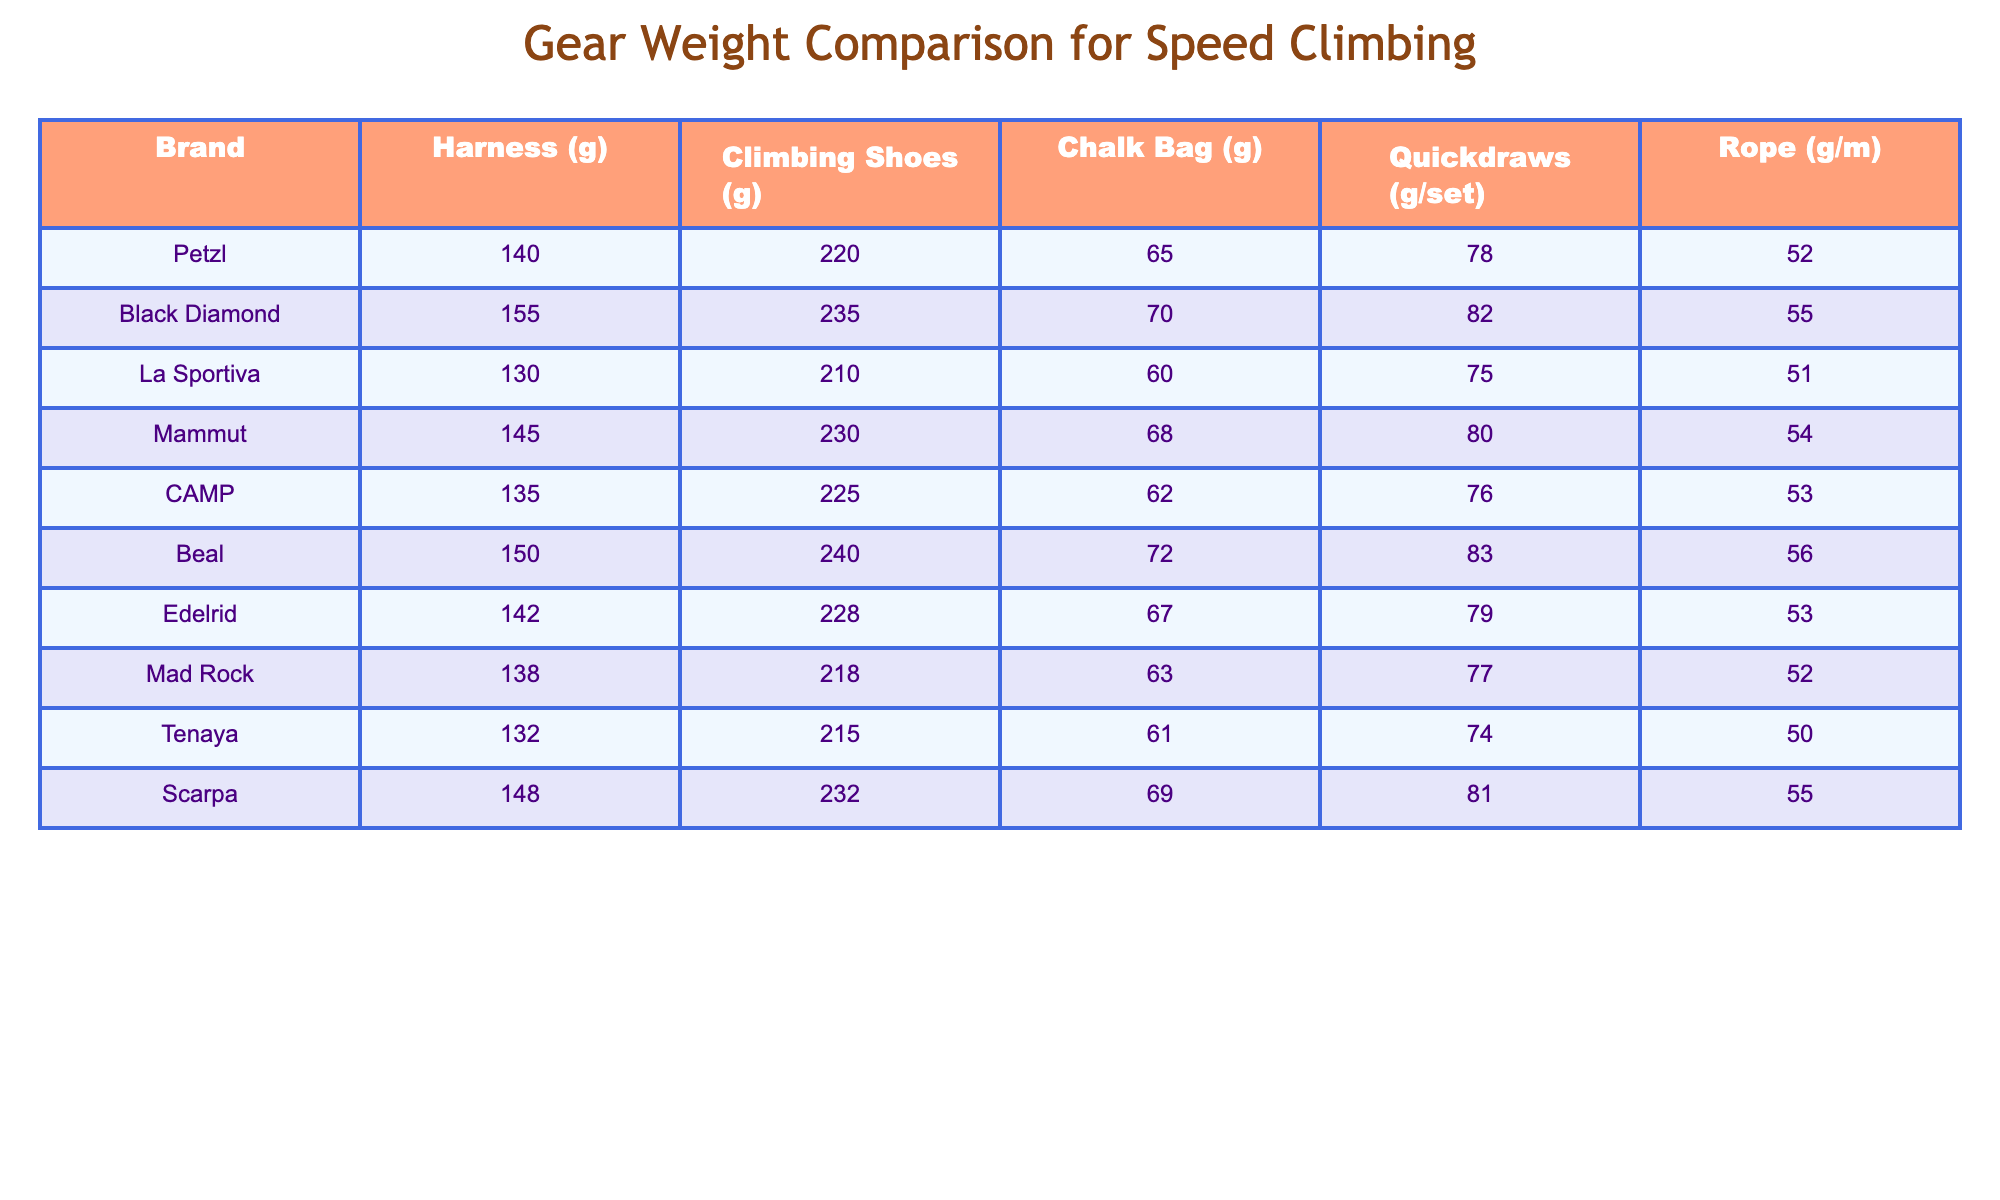What is the lightest harness among the brands? By comparing the weights of the harnesses listed in the table, Petzl has the lightest harness weight of 140 grams.
Answer: 140 grams Which brand has the heaviest climbing shoes? The table shows Black Diamond with climbing shoes weighing 235 grams, which is the heaviest among all the listed brands.
Answer: 235 grams How many grams do the quickdraws weigh if you combine the lightest and heaviest? The lightest quickdraws come from La Sportiva at 75 grams and the heaviest from Beal at 83 grams. The total weight is 75 + 83 = 158 grams.
Answer: 158 grams Is the weight of the Chalk Bag from CAMP heavier than that from Mad Rock? The Chalk Bag from CAMP weighs 62 grams, while Mad Rock's is 63 grams, making CAMP's chalk bag lighter.
Answer: No What is the average weight of the ropes across all brands? Adding all the rope weights gives 52 + 55 + 51 + 54 + 53 + 56 + 53 + 50 + 55 + 54 = 530 grams. Dividing this by the number of brands (10) results in an average of 53 grams.
Answer: 53 grams Which brand has the lightest overall gear weight, considering harness, climbing shoes, chalk bag, quickdraws, and rope? To find the lightest brand's overall gear weight, we need to sum the weights for each brand. La Sportiva: 130 + 210 + 60 + 75 + 51 = 526 grams is the smallest total.
Answer: La Sportiva Are Beal's quickdraws lighter than those from Edelrid? Beal's quickdraws weigh 83 grams, while Edelrid's are 79 grams, which means Beal's quickdraws are heavier.
Answer: No Who has the second lightest chalk bag? Comparing the chalk bag weights, La Sportiva has the lightest at 60 grams, and the second lightest is CAMP at 62 grams.
Answer: CAMP How much heavier is Black Diamond's climbing shoes compared to Petzl's? Black Diamond's climbing shoes weigh 235 grams, while Petzl's weigh 220 grams. The difference is 235 - 220 = 15 grams.
Answer: 15 grams What is the total weight difference between the lightest and heaviest harness? The lightest harness from Petzl is 140 grams, and the heaviest from Beal is 155 grams. The difference is 155 - 140 = 15 grams.
Answer: 15 grams 